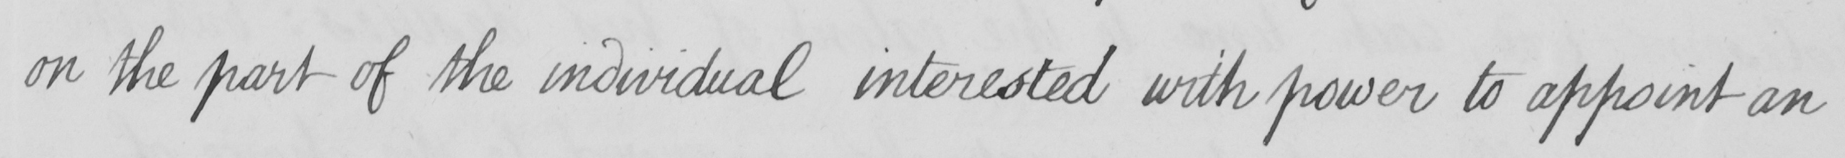What text is written in this handwritten line? on the part of the individual interested with power to appoint an 